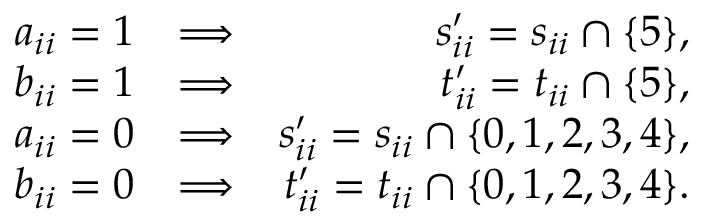<formula> <loc_0><loc_0><loc_500><loc_500>\begin{array} { r l r } { a _ { i i } = 1 } & { \Longrightarrow } & { s _ { i i } ^ { \prime } = s _ { i i } \cap \{ 5 \} , } \\ { b _ { i i } = 1 } & { \Longrightarrow } & { t _ { i i } ^ { \prime } = t _ { i i } \cap \{ 5 \} , } \\ { a _ { i i } = 0 } & { \Longrightarrow } & { s _ { i i } ^ { \prime } = s _ { i i } \cap \{ 0 , 1 , 2 , 3 , 4 \} , } \\ { b _ { i i } = 0 } & { \Longrightarrow } & { t _ { i i } ^ { \prime } = t _ { i i } \cap \{ 0 , 1 , 2 , 3 , 4 \} . } \end{array}</formula> 